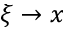<formula> <loc_0><loc_0><loc_500><loc_500>\xi \to x</formula> 